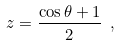<formula> <loc_0><loc_0><loc_500><loc_500>z = \frac { \cos \theta + 1 } { 2 } \ ,</formula> 